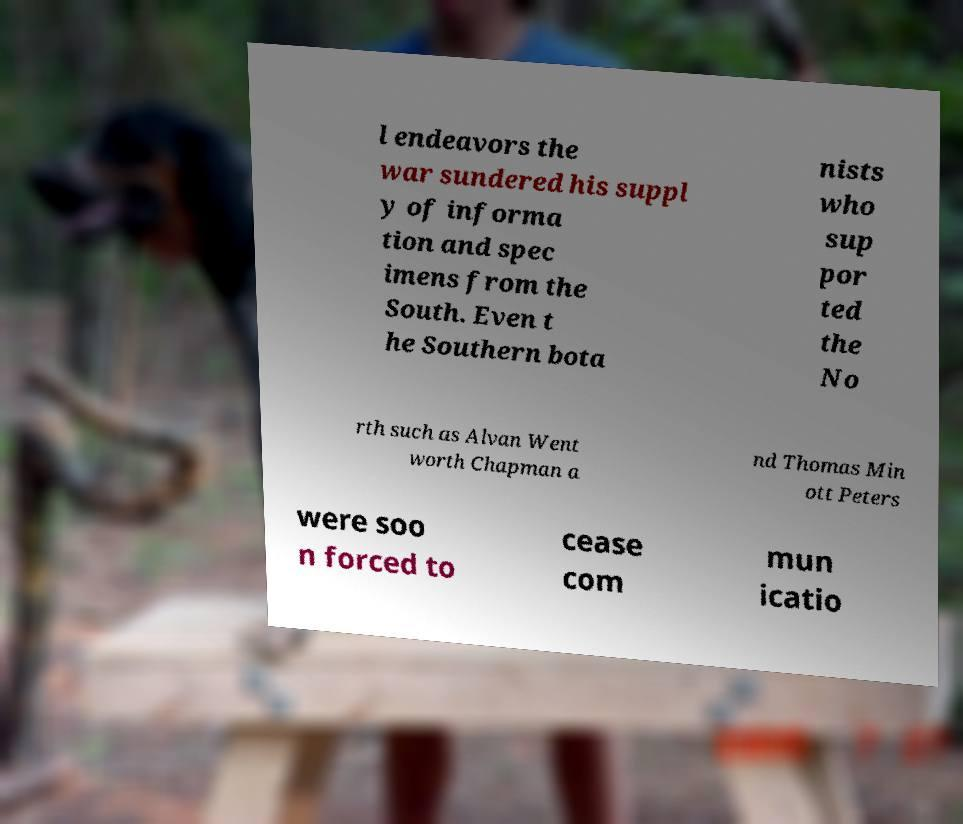Can you accurately transcribe the text from the provided image for me? l endeavors the war sundered his suppl y of informa tion and spec imens from the South. Even t he Southern bota nists who sup por ted the No rth such as Alvan Went worth Chapman a nd Thomas Min ott Peters were soo n forced to cease com mun icatio 